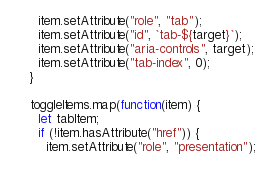<code> <loc_0><loc_0><loc_500><loc_500><_JavaScript_>      item.setAttribute("role", "tab");
      item.setAttribute("id", `tab-${target}`);
      item.setAttribute("aria-controls", target);
      item.setAttribute("tab-index", 0);
    }

    toggleItems.map(function(item) {
      let tabItem;
      if (!item.hasAttribute("href")) {
        item.setAttribute("role", "presentation");</code> 